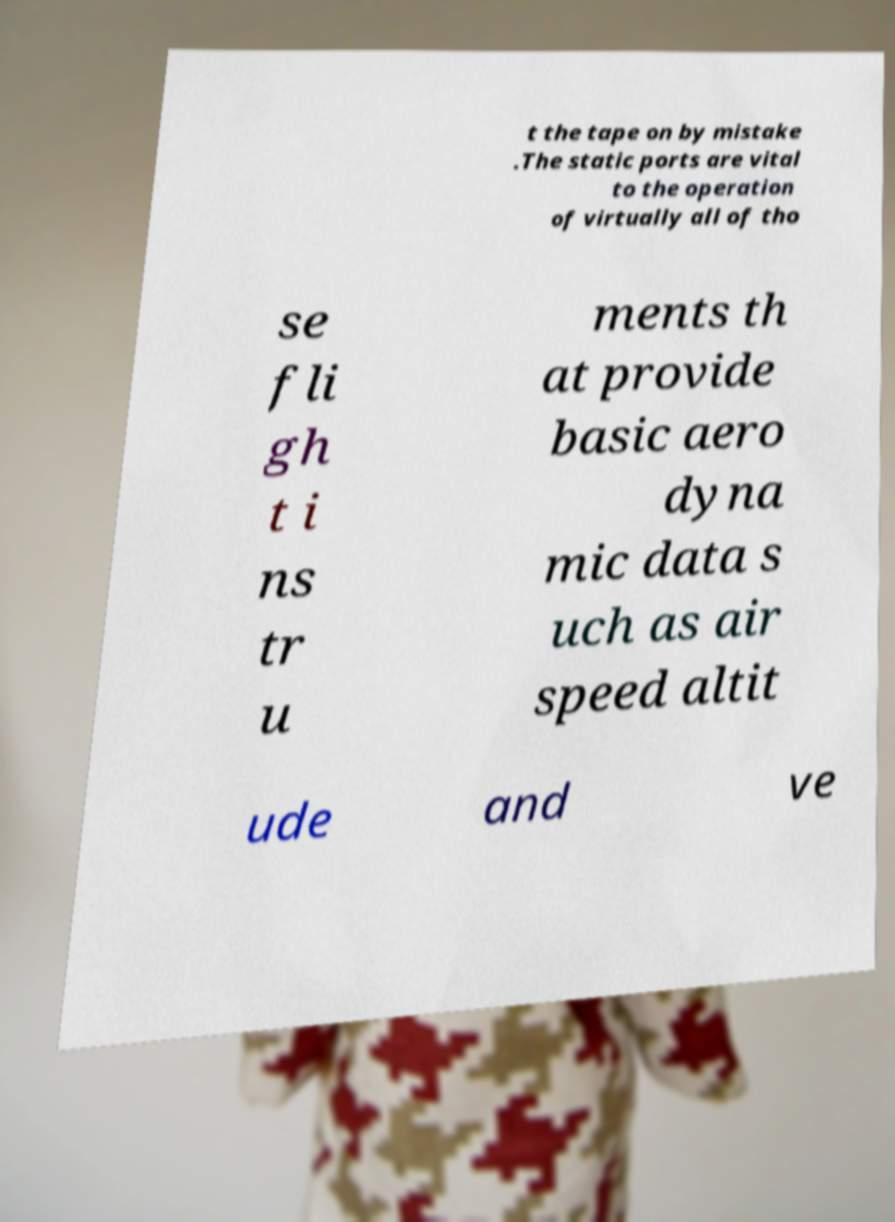Please identify and transcribe the text found in this image. t the tape on by mistake .The static ports are vital to the operation of virtually all of tho se fli gh t i ns tr u ments th at provide basic aero dyna mic data s uch as air speed altit ude and ve 